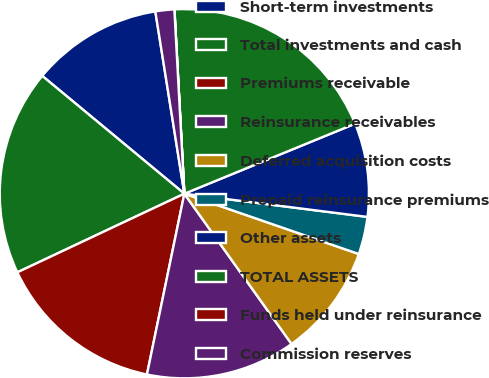Convert chart to OTSL. <chart><loc_0><loc_0><loc_500><loc_500><pie_chart><fcel>Short-term investments<fcel>Total investments and cash<fcel>Premiums receivable<fcel>Reinsurance receivables<fcel>Deferred acquisition costs<fcel>Prepaid reinsurance premiums<fcel>Other assets<fcel>TOTAL ASSETS<fcel>Funds held under reinsurance<fcel>Commission reserves<nl><fcel>11.47%<fcel>18.02%<fcel>14.75%<fcel>13.11%<fcel>9.84%<fcel>3.29%<fcel>8.2%<fcel>19.66%<fcel>0.01%<fcel>1.65%<nl></chart> 